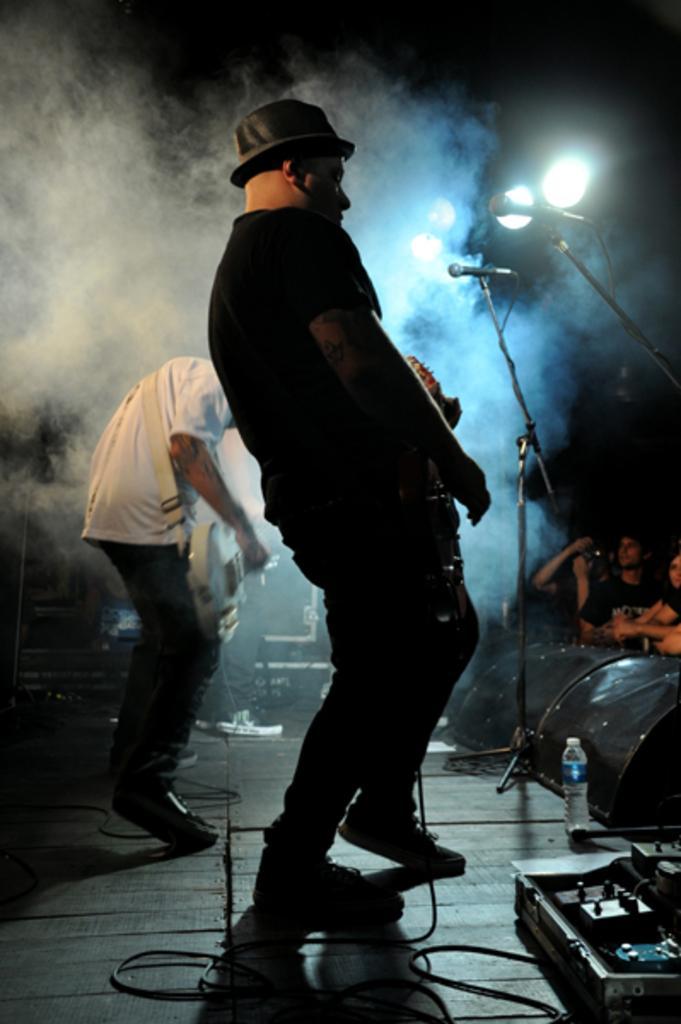Describe this image in one or two sentences. In this image we can see person standing on the dais and holding musical instruments in their hands. In addition to this we can see mics, mic stands, electric lights, disposal bottle, cables and persons standing on the floor. 